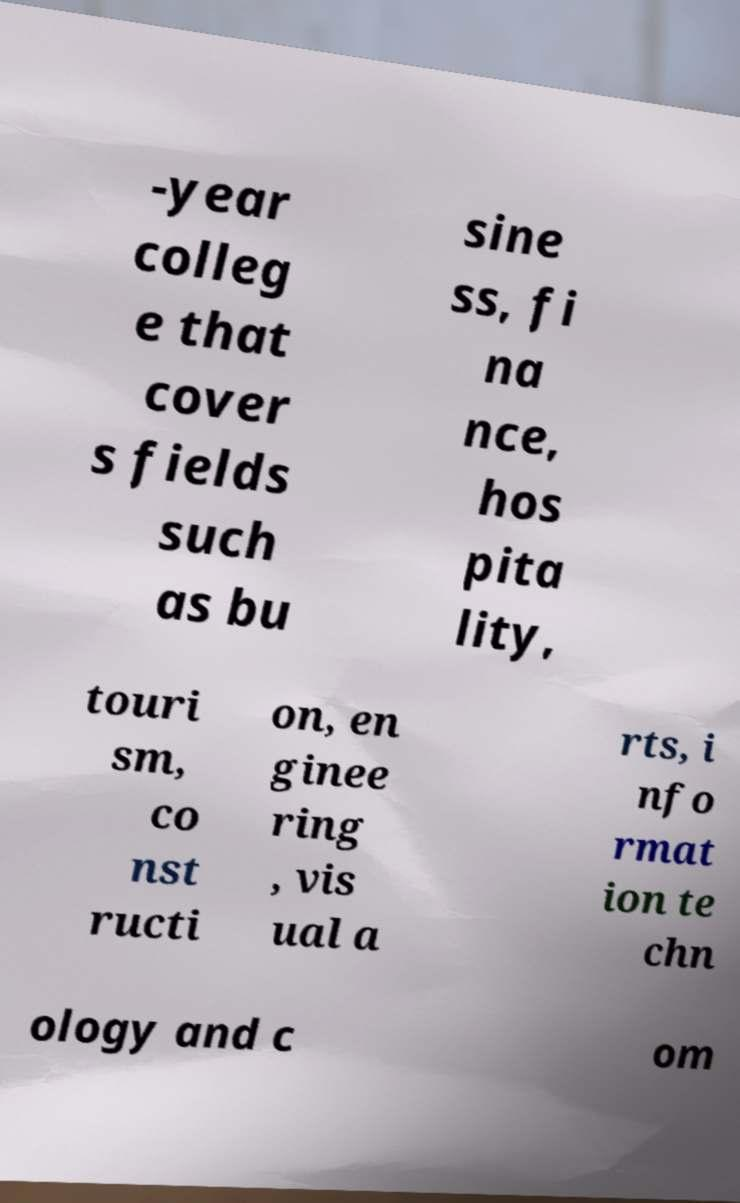Please identify and transcribe the text found in this image. -year colleg e that cover s fields such as bu sine ss, fi na nce, hos pita lity, touri sm, co nst ructi on, en ginee ring , vis ual a rts, i nfo rmat ion te chn ology and c om 